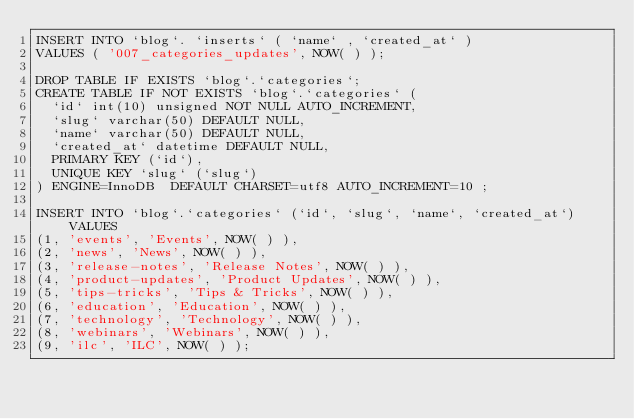<code> <loc_0><loc_0><loc_500><loc_500><_SQL_>INSERT INTO `blog`. `inserts` ( `name` , `created_at` )
VALUES ( '007_categories_updates', NOW( ) );

DROP TABLE IF EXISTS `blog`.`categories`;
CREATE TABLE IF NOT EXISTS `blog`.`categories` (
  `id` int(10) unsigned NOT NULL AUTO_INCREMENT,
  `slug` varchar(50) DEFAULT NULL,
  `name` varchar(50) DEFAULT NULL,
  `created_at` datetime DEFAULT NULL,
  PRIMARY KEY (`id`),
  UNIQUE KEY `slug` (`slug`)
) ENGINE=InnoDB  DEFAULT CHARSET=utf8 AUTO_INCREMENT=10 ;

INSERT INTO `blog`.`categories` (`id`, `slug`, `name`, `created_at`) VALUES
(1, 'events', 'Events', NOW( ) ),
(2, 'news', 'News', NOW( ) ),
(3, 'release-notes', 'Release Notes', NOW( ) ),
(4, 'product-updates', 'Product Updates', NOW( ) ),
(5, 'tips-tricks', 'Tips & Tricks', NOW( ) ),
(6, 'education', 'Education', NOW( ) ),
(7, 'technology', 'Technology', NOW( ) ),
(8, 'webinars', 'Webinars', NOW( ) ),
(9, 'ilc', 'ILC', NOW( ) );</code> 